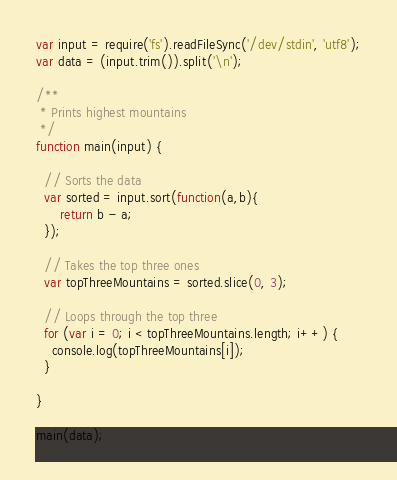<code> <loc_0><loc_0><loc_500><loc_500><_JavaScript_>var input = require('fs').readFileSync('/dev/stdin', 'utf8');
var data = (input.trim()).split('\n');

/**
 * Prints highest mountains
 */
function main(input) {

  // Sorts the data
  var sorted = input.sort(function(a,b){
      return b - a;
  });

  // Takes the top three ones
  var topThreeMountains = sorted.slice(0, 3);

  // Loops through the top three
  for (var i = 0; i < topThreeMountains.length; i++) {
    console.log(topThreeMountains[i]);
  }

}

main(data);</code> 